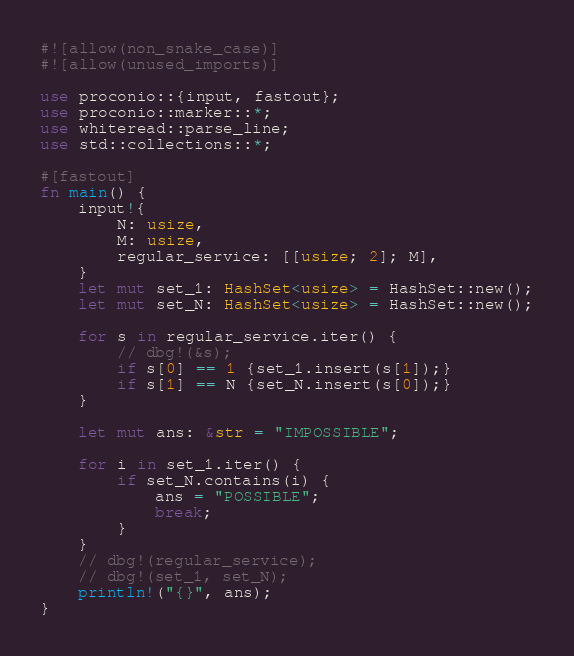Convert code to text. <code><loc_0><loc_0><loc_500><loc_500><_Rust_>#![allow(non_snake_case)]
#![allow(unused_imports)]
 
use proconio::{input, fastout};
use proconio::marker::*;
use whiteread::parse_line;
use std::collections::*;

#[fastout]
fn main() {
    input!{
        N: usize,
        M: usize,
        regular_service: [[usize; 2]; M],
    }
    let mut set_1: HashSet<usize> = HashSet::new();
    let mut set_N: HashSet<usize> = HashSet::new();
    
    for s in regular_service.iter() {
        // dbg!(&s);
        if s[0] == 1 {set_1.insert(s[1]);}
        if s[1] == N {set_N.insert(s[0]);}
    }

    let mut ans: &str = "IMPOSSIBLE";

    for i in set_1.iter() {
        if set_N.contains(i) {
            ans = "POSSIBLE";
            break;
        }
    }
    // dbg!(regular_service);
    // dbg!(set_1, set_N);
    println!("{}", ans);
}
</code> 